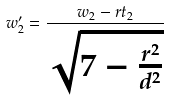Convert formula to latex. <formula><loc_0><loc_0><loc_500><loc_500>w _ { 2 } ^ { \prime } = \frac { w _ { 2 } - r t _ { 2 } } { \sqrt { 7 - \frac { r ^ { 2 } } { d ^ { 2 } } } }</formula> 